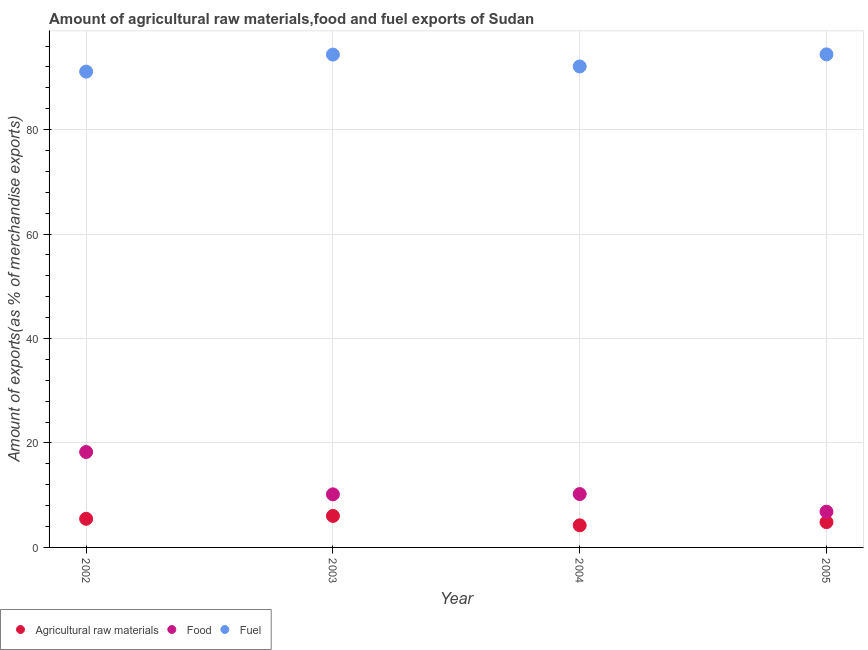How many different coloured dotlines are there?
Keep it short and to the point. 3. What is the percentage of fuel exports in 2003?
Provide a short and direct response. 94.37. Across all years, what is the maximum percentage of food exports?
Give a very brief answer. 18.27. Across all years, what is the minimum percentage of raw materials exports?
Offer a terse response. 4.23. In which year was the percentage of food exports maximum?
Give a very brief answer. 2002. What is the total percentage of fuel exports in the graph?
Give a very brief answer. 371.99. What is the difference between the percentage of food exports in 2004 and that in 2005?
Provide a succinct answer. 3.37. What is the difference between the percentage of raw materials exports in 2005 and the percentage of fuel exports in 2004?
Your response must be concise. -87.25. What is the average percentage of raw materials exports per year?
Offer a terse response. 5.15. In the year 2005, what is the difference between the percentage of raw materials exports and percentage of fuel exports?
Provide a short and direct response. -89.57. In how many years, is the percentage of fuel exports greater than 68 %?
Make the answer very short. 4. What is the ratio of the percentage of food exports in 2004 to that in 2005?
Give a very brief answer. 1.49. Is the percentage of raw materials exports in 2004 less than that in 2005?
Ensure brevity in your answer.  Yes. Is the difference between the percentage of fuel exports in 2002 and 2005 greater than the difference between the percentage of raw materials exports in 2002 and 2005?
Your answer should be compact. No. What is the difference between the highest and the second highest percentage of fuel exports?
Give a very brief answer. 0.04. What is the difference between the highest and the lowest percentage of raw materials exports?
Your answer should be compact. 1.8. In how many years, is the percentage of fuel exports greater than the average percentage of fuel exports taken over all years?
Provide a short and direct response. 2. Is the sum of the percentage of raw materials exports in 2003 and 2004 greater than the maximum percentage of fuel exports across all years?
Ensure brevity in your answer.  No. Is it the case that in every year, the sum of the percentage of raw materials exports and percentage of food exports is greater than the percentage of fuel exports?
Your answer should be very brief. No. Is the percentage of fuel exports strictly less than the percentage of raw materials exports over the years?
Make the answer very short. No. What is the difference between two consecutive major ticks on the Y-axis?
Offer a very short reply. 20. Are the values on the major ticks of Y-axis written in scientific E-notation?
Your answer should be very brief. No. Does the graph contain grids?
Your answer should be compact. Yes. How many legend labels are there?
Make the answer very short. 3. What is the title of the graph?
Ensure brevity in your answer.  Amount of agricultural raw materials,food and fuel exports of Sudan. What is the label or title of the X-axis?
Ensure brevity in your answer.  Year. What is the label or title of the Y-axis?
Make the answer very short. Amount of exports(as % of merchandise exports). What is the Amount of exports(as % of merchandise exports) in Agricultural raw materials in 2002?
Offer a terse response. 5.48. What is the Amount of exports(as % of merchandise exports) of Food in 2002?
Provide a succinct answer. 18.27. What is the Amount of exports(as % of merchandise exports) in Fuel in 2002?
Ensure brevity in your answer.  91.11. What is the Amount of exports(as % of merchandise exports) in Agricultural raw materials in 2003?
Your answer should be compact. 6.03. What is the Amount of exports(as % of merchandise exports) in Food in 2003?
Give a very brief answer. 10.16. What is the Amount of exports(as % of merchandise exports) of Fuel in 2003?
Give a very brief answer. 94.37. What is the Amount of exports(as % of merchandise exports) of Agricultural raw materials in 2004?
Keep it short and to the point. 4.23. What is the Amount of exports(as % of merchandise exports) in Food in 2004?
Ensure brevity in your answer.  10.22. What is the Amount of exports(as % of merchandise exports) in Fuel in 2004?
Make the answer very short. 92.1. What is the Amount of exports(as % of merchandise exports) of Agricultural raw materials in 2005?
Keep it short and to the point. 4.84. What is the Amount of exports(as % of merchandise exports) in Food in 2005?
Provide a short and direct response. 6.84. What is the Amount of exports(as % of merchandise exports) of Fuel in 2005?
Give a very brief answer. 94.41. Across all years, what is the maximum Amount of exports(as % of merchandise exports) in Agricultural raw materials?
Your answer should be compact. 6.03. Across all years, what is the maximum Amount of exports(as % of merchandise exports) of Food?
Provide a succinct answer. 18.27. Across all years, what is the maximum Amount of exports(as % of merchandise exports) of Fuel?
Give a very brief answer. 94.41. Across all years, what is the minimum Amount of exports(as % of merchandise exports) in Agricultural raw materials?
Give a very brief answer. 4.23. Across all years, what is the minimum Amount of exports(as % of merchandise exports) in Food?
Provide a succinct answer. 6.84. Across all years, what is the minimum Amount of exports(as % of merchandise exports) in Fuel?
Provide a succinct answer. 91.11. What is the total Amount of exports(as % of merchandise exports) of Agricultural raw materials in the graph?
Give a very brief answer. 20.59. What is the total Amount of exports(as % of merchandise exports) in Food in the graph?
Ensure brevity in your answer.  45.49. What is the total Amount of exports(as % of merchandise exports) in Fuel in the graph?
Make the answer very short. 371.99. What is the difference between the Amount of exports(as % of merchandise exports) in Agricultural raw materials in 2002 and that in 2003?
Offer a very short reply. -0.55. What is the difference between the Amount of exports(as % of merchandise exports) of Food in 2002 and that in 2003?
Ensure brevity in your answer.  8.11. What is the difference between the Amount of exports(as % of merchandise exports) of Fuel in 2002 and that in 2003?
Your answer should be compact. -3.26. What is the difference between the Amount of exports(as % of merchandise exports) of Agricultural raw materials in 2002 and that in 2004?
Keep it short and to the point. 1.25. What is the difference between the Amount of exports(as % of merchandise exports) of Food in 2002 and that in 2004?
Offer a very short reply. 8.05. What is the difference between the Amount of exports(as % of merchandise exports) of Fuel in 2002 and that in 2004?
Offer a very short reply. -0.99. What is the difference between the Amount of exports(as % of merchandise exports) in Agricultural raw materials in 2002 and that in 2005?
Offer a terse response. 0.64. What is the difference between the Amount of exports(as % of merchandise exports) of Food in 2002 and that in 2005?
Your response must be concise. 11.43. What is the difference between the Amount of exports(as % of merchandise exports) of Fuel in 2002 and that in 2005?
Offer a very short reply. -3.3. What is the difference between the Amount of exports(as % of merchandise exports) of Agricultural raw materials in 2003 and that in 2004?
Offer a very short reply. 1.8. What is the difference between the Amount of exports(as % of merchandise exports) in Food in 2003 and that in 2004?
Offer a very short reply. -0.05. What is the difference between the Amount of exports(as % of merchandise exports) of Fuel in 2003 and that in 2004?
Your answer should be compact. 2.27. What is the difference between the Amount of exports(as % of merchandise exports) in Agricultural raw materials in 2003 and that in 2005?
Ensure brevity in your answer.  1.19. What is the difference between the Amount of exports(as % of merchandise exports) in Food in 2003 and that in 2005?
Your answer should be compact. 3.32. What is the difference between the Amount of exports(as % of merchandise exports) in Fuel in 2003 and that in 2005?
Your answer should be very brief. -0.04. What is the difference between the Amount of exports(as % of merchandise exports) of Agricultural raw materials in 2004 and that in 2005?
Your answer should be compact. -0.61. What is the difference between the Amount of exports(as % of merchandise exports) of Food in 2004 and that in 2005?
Give a very brief answer. 3.37. What is the difference between the Amount of exports(as % of merchandise exports) of Fuel in 2004 and that in 2005?
Provide a short and direct response. -2.31. What is the difference between the Amount of exports(as % of merchandise exports) in Agricultural raw materials in 2002 and the Amount of exports(as % of merchandise exports) in Food in 2003?
Provide a short and direct response. -4.68. What is the difference between the Amount of exports(as % of merchandise exports) of Agricultural raw materials in 2002 and the Amount of exports(as % of merchandise exports) of Fuel in 2003?
Give a very brief answer. -88.89. What is the difference between the Amount of exports(as % of merchandise exports) of Food in 2002 and the Amount of exports(as % of merchandise exports) of Fuel in 2003?
Your response must be concise. -76.1. What is the difference between the Amount of exports(as % of merchandise exports) in Agricultural raw materials in 2002 and the Amount of exports(as % of merchandise exports) in Food in 2004?
Offer a very short reply. -4.73. What is the difference between the Amount of exports(as % of merchandise exports) in Agricultural raw materials in 2002 and the Amount of exports(as % of merchandise exports) in Fuel in 2004?
Keep it short and to the point. -86.61. What is the difference between the Amount of exports(as % of merchandise exports) of Food in 2002 and the Amount of exports(as % of merchandise exports) of Fuel in 2004?
Your answer should be compact. -73.83. What is the difference between the Amount of exports(as % of merchandise exports) in Agricultural raw materials in 2002 and the Amount of exports(as % of merchandise exports) in Food in 2005?
Ensure brevity in your answer.  -1.36. What is the difference between the Amount of exports(as % of merchandise exports) in Agricultural raw materials in 2002 and the Amount of exports(as % of merchandise exports) in Fuel in 2005?
Ensure brevity in your answer.  -88.93. What is the difference between the Amount of exports(as % of merchandise exports) of Food in 2002 and the Amount of exports(as % of merchandise exports) of Fuel in 2005?
Offer a very short reply. -76.14. What is the difference between the Amount of exports(as % of merchandise exports) in Agricultural raw materials in 2003 and the Amount of exports(as % of merchandise exports) in Food in 2004?
Provide a succinct answer. -4.19. What is the difference between the Amount of exports(as % of merchandise exports) of Agricultural raw materials in 2003 and the Amount of exports(as % of merchandise exports) of Fuel in 2004?
Your response must be concise. -86.07. What is the difference between the Amount of exports(as % of merchandise exports) of Food in 2003 and the Amount of exports(as % of merchandise exports) of Fuel in 2004?
Ensure brevity in your answer.  -81.93. What is the difference between the Amount of exports(as % of merchandise exports) in Agricultural raw materials in 2003 and the Amount of exports(as % of merchandise exports) in Food in 2005?
Your answer should be compact. -0.81. What is the difference between the Amount of exports(as % of merchandise exports) in Agricultural raw materials in 2003 and the Amount of exports(as % of merchandise exports) in Fuel in 2005?
Give a very brief answer. -88.38. What is the difference between the Amount of exports(as % of merchandise exports) of Food in 2003 and the Amount of exports(as % of merchandise exports) of Fuel in 2005?
Your answer should be compact. -84.25. What is the difference between the Amount of exports(as % of merchandise exports) of Agricultural raw materials in 2004 and the Amount of exports(as % of merchandise exports) of Food in 2005?
Provide a succinct answer. -2.61. What is the difference between the Amount of exports(as % of merchandise exports) of Agricultural raw materials in 2004 and the Amount of exports(as % of merchandise exports) of Fuel in 2005?
Keep it short and to the point. -90.18. What is the difference between the Amount of exports(as % of merchandise exports) in Food in 2004 and the Amount of exports(as % of merchandise exports) in Fuel in 2005?
Offer a terse response. -84.2. What is the average Amount of exports(as % of merchandise exports) of Agricultural raw materials per year?
Offer a very short reply. 5.15. What is the average Amount of exports(as % of merchandise exports) of Food per year?
Your answer should be compact. 11.37. What is the average Amount of exports(as % of merchandise exports) in Fuel per year?
Give a very brief answer. 93. In the year 2002, what is the difference between the Amount of exports(as % of merchandise exports) in Agricultural raw materials and Amount of exports(as % of merchandise exports) in Food?
Offer a very short reply. -12.78. In the year 2002, what is the difference between the Amount of exports(as % of merchandise exports) of Agricultural raw materials and Amount of exports(as % of merchandise exports) of Fuel?
Keep it short and to the point. -85.62. In the year 2002, what is the difference between the Amount of exports(as % of merchandise exports) of Food and Amount of exports(as % of merchandise exports) of Fuel?
Ensure brevity in your answer.  -72.84. In the year 2003, what is the difference between the Amount of exports(as % of merchandise exports) in Agricultural raw materials and Amount of exports(as % of merchandise exports) in Food?
Offer a very short reply. -4.13. In the year 2003, what is the difference between the Amount of exports(as % of merchandise exports) in Agricultural raw materials and Amount of exports(as % of merchandise exports) in Fuel?
Your answer should be compact. -88.34. In the year 2003, what is the difference between the Amount of exports(as % of merchandise exports) of Food and Amount of exports(as % of merchandise exports) of Fuel?
Your response must be concise. -84.21. In the year 2004, what is the difference between the Amount of exports(as % of merchandise exports) of Agricultural raw materials and Amount of exports(as % of merchandise exports) of Food?
Your answer should be compact. -5.98. In the year 2004, what is the difference between the Amount of exports(as % of merchandise exports) in Agricultural raw materials and Amount of exports(as % of merchandise exports) in Fuel?
Provide a succinct answer. -87.86. In the year 2004, what is the difference between the Amount of exports(as % of merchandise exports) of Food and Amount of exports(as % of merchandise exports) of Fuel?
Offer a terse response. -81.88. In the year 2005, what is the difference between the Amount of exports(as % of merchandise exports) of Agricultural raw materials and Amount of exports(as % of merchandise exports) of Food?
Provide a succinct answer. -2. In the year 2005, what is the difference between the Amount of exports(as % of merchandise exports) in Agricultural raw materials and Amount of exports(as % of merchandise exports) in Fuel?
Your response must be concise. -89.57. In the year 2005, what is the difference between the Amount of exports(as % of merchandise exports) of Food and Amount of exports(as % of merchandise exports) of Fuel?
Give a very brief answer. -87.57. What is the ratio of the Amount of exports(as % of merchandise exports) of Agricultural raw materials in 2002 to that in 2003?
Your response must be concise. 0.91. What is the ratio of the Amount of exports(as % of merchandise exports) in Food in 2002 to that in 2003?
Keep it short and to the point. 1.8. What is the ratio of the Amount of exports(as % of merchandise exports) of Fuel in 2002 to that in 2003?
Ensure brevity in your answer.  0.97. What is the ratio of the Amount of exports(as % of merchandise exports) in Agricultural raw materials in 2002 to that in 2004?
Offer a very short reply. 1.3. What is the ratio of the Amount of exports(as % of merchandise exports) of Food in 2002 to that in 2004?
Your answer should be very brief. 1.79. What is the ratio of the Amount of exports(as % of merchandise exports) of Fuel in 2002 to that in 2004?
Offer a terse response. 0.99. What is the ratio of the Amount of exports(as % of merchandise exports) of Agricultural raw materials in 2002 to that in 2005?
Your response must be concise. 1.13. What is the ratio of the Amount of exports(as % of merchandise exports) of Food in 2002 to that in 2005?
Offer a very short reply. 2.67. What is the ratio of the Amount of exports(as % of merchandise exports) of Agricultural raw materials in 2003 to that in 2004?
Provide a succinct answer. 1.42. What is the ratio of the Amount of exports(as % of merchandise exports) in Food in 2003 to that in 2004?
Your answer should be compact. 0.99. What is the ratio of the Amount of exports(as % of merchandise exports) of Fuel in 2003 to that in 2004?
Keep it short and to the point. 1.02. What is the ratio of the Amount of exports(as % of merchandise exports) of Agricultural raw materials in 2003 to that in 2005?
Make the answer very short. 1.24. What is the ratio of the Amount of exports(as % of merchandise exports) in Food in 2003 to that in 2005?
Your response must be concise. 1.49. What is the ratio of the Amount of exports(as % of merchandise exports) in Fuel in 2003 to that in 2005?
Give a very brief answer. 1. What is the ratio of the Amount of exports(as % of merchandise exports) in Agricultural raw materials in 2004 to that in 2005?
Keep it short and to the point. 0.87. What is the ratio of the Amount of exports(as % of merchandise exports) of Food in 2004 to that in 2005?
Your response must be concise. 1.49. What is the ratio of the Amount of exports(as % of merchandise exports) of Fuel in 2004 to that in 2005?
Your response must be concise. 0.98. What is the difference between the highest and the second highest Amount of exports(as % of merchandise exports) of Agricultural raw materials?
Your response must be concise. 0.55. What is the difference between the highest and the second highest Amount of exports(as % of merchandise exports) in Food?
Your answer should be compact. 8.05. What is the difference between the highest and the second highest Amount of exports(as % of merchandise exports) in Fuel?
Provide a short and direct response. 0.04. What is the difference between the highest and the lowest Amount of exports(as % of merchandise exports) of Agricultural raw materials?
Keep it short and to the point. 1.8. What is the difference between the highest and the lowest Amount of exports(as % of merchandise exports) of Food?
Offer a terse response. 11.43. What is the difference between the highest and the lowest Amount of exports(as % of merchandise exports) in Fuel?
Your response must be concise. 3.3. 